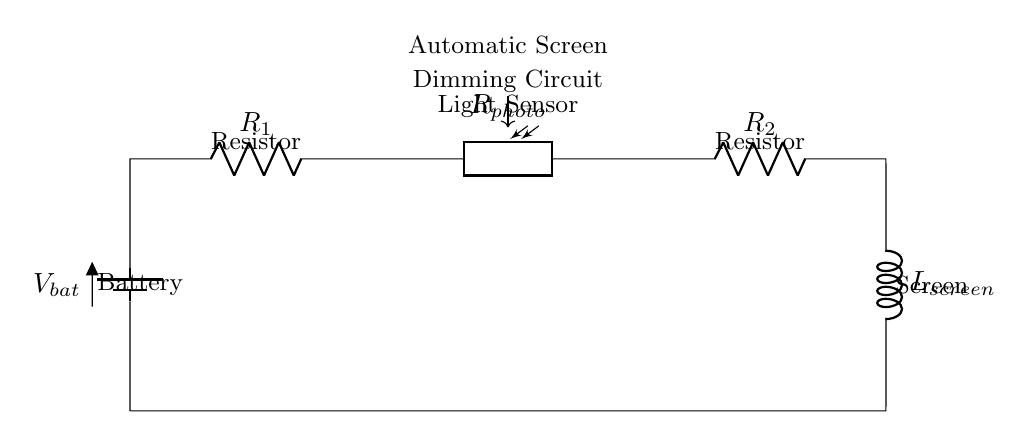What type of circuit is this? This circuit is a series circuit, as all components are connected end-to-end in a single path for current to flow.
Answer: Series circuit What does the photoresistor do? The photoresistor acts as a light sensor, adjusting the resistance based on the light conditions to influence the circuit operation for automatic dimming.
Answer: Light sensor Which component is represented by L in the circuit? The component represented by L is the screen, which receives power from the circuit and adjusts its brightness based on the input from the photoresistor.
Answer: Screen How many resistors are in the circuit? There are two resistors (R1 and R2) in the circuit, as indicated in the diagram, both of which affect the overall resistance and voltage drop in the circuit.
Answer: Two How does ambient light affect this circuit? Ambient light alters the resistance of the photoresistor, which in turn changes the current in the circuit, allowing the screen to dim or brighten automatically.
Answer: It changes current What is the function of R1 in this circuit? R1 serves to limit the current flow in the circuit, protecting other components and ensuring proper functioning of the photoresistor and screen based on the light conditions.
Answer: Current limiter 